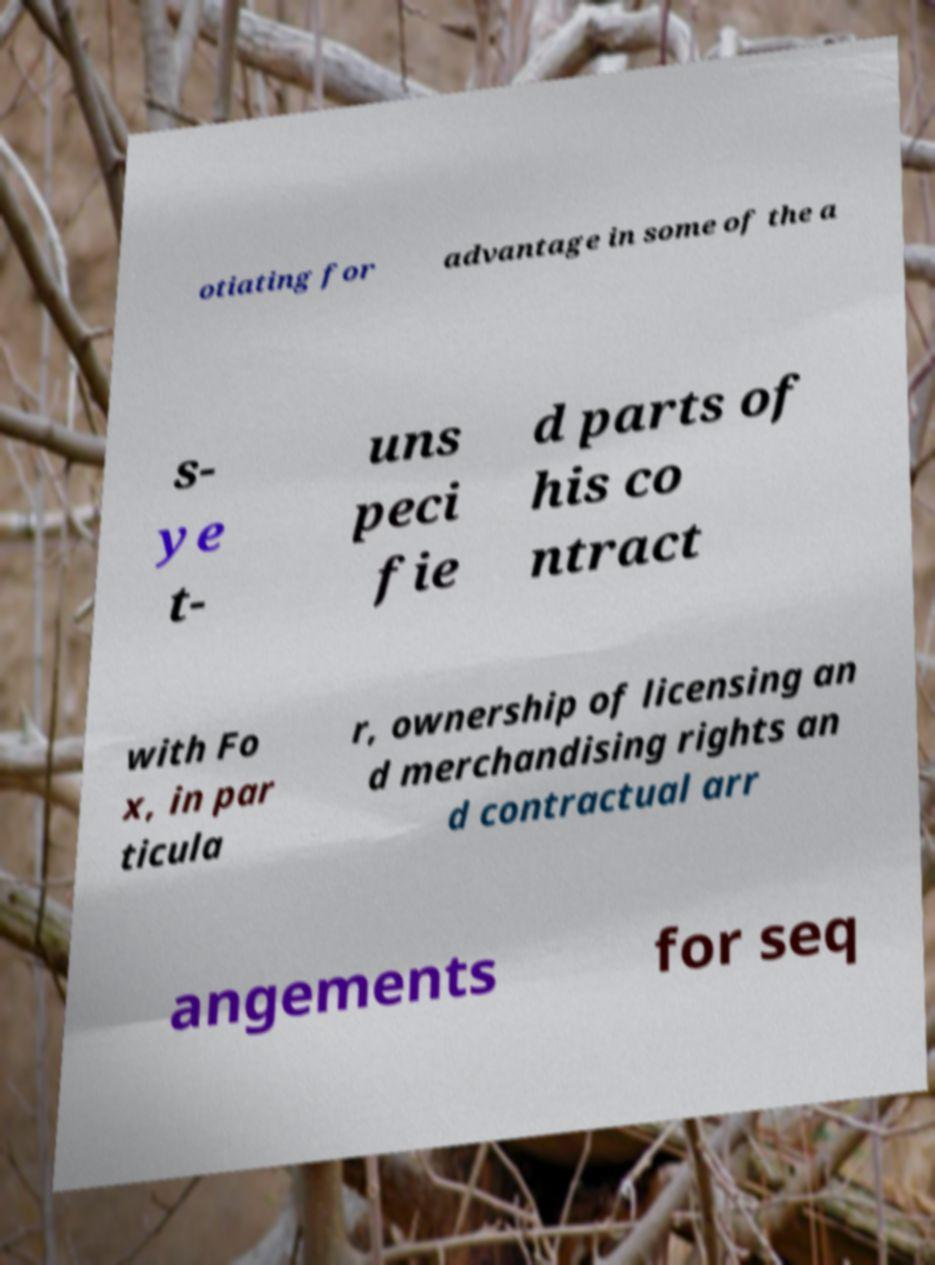There's text embedded in this image that I need extracted. Can you transcribe it verbatim? otiating for advantage in some of the a s- ye t- uns peci fie d parts of his co ntract with Fo x, in par ticula r, ownership of licensing an d merchandising rights an d contractual arr angements for seq 